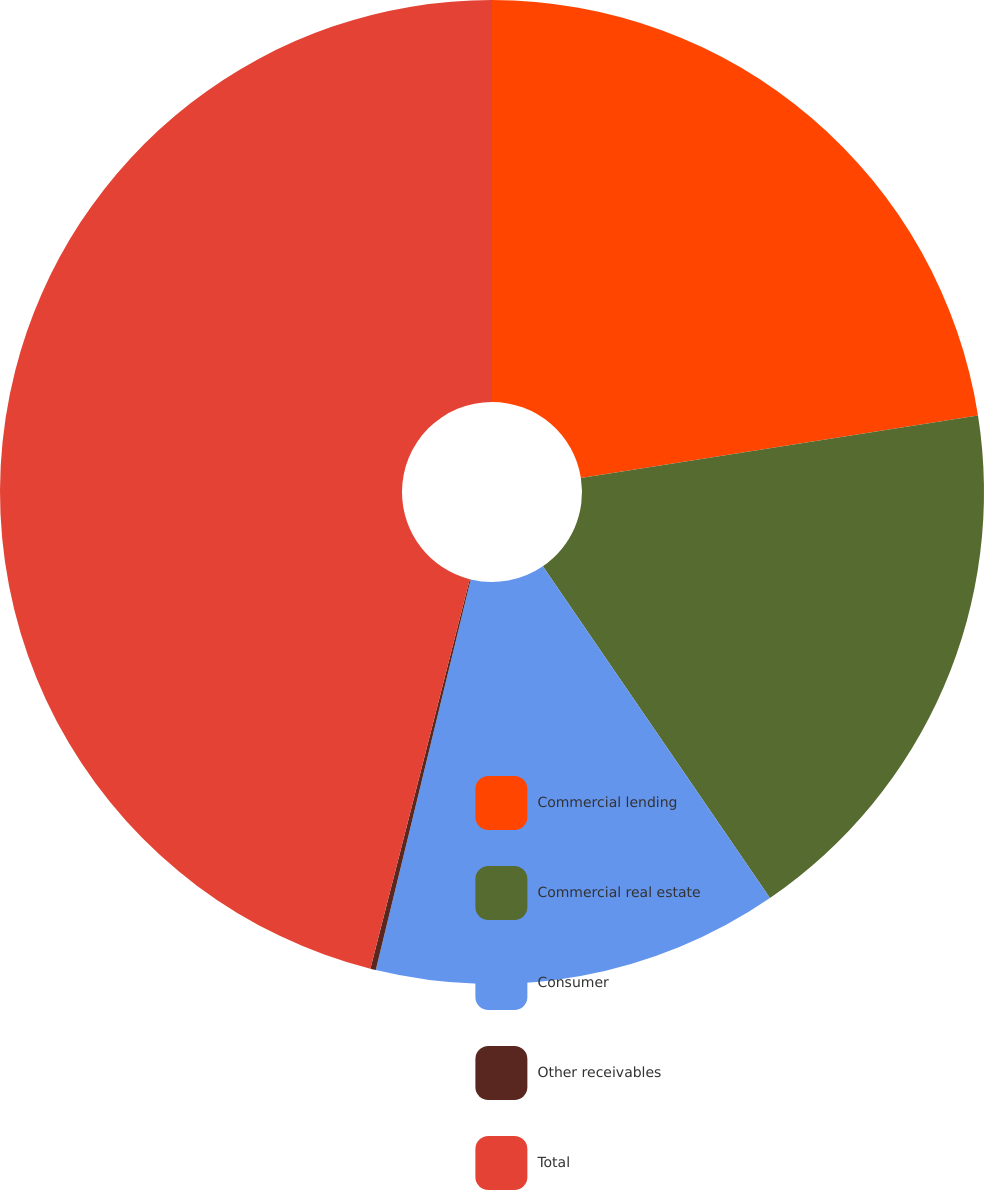Convert chart to OTSL. <chart><loc_0><loc_0><loc_500><loc_500><pie_chart><fcel>Commercial lending<fcel>Commercial real estate<fcel>Consumer<fcel>Other receivables<fcel>Total<nl><fcel>22.51%<fcel>17.93%<fcel>13.35%<fcel>0.18%<fcel>46.02%<nl></chart> 